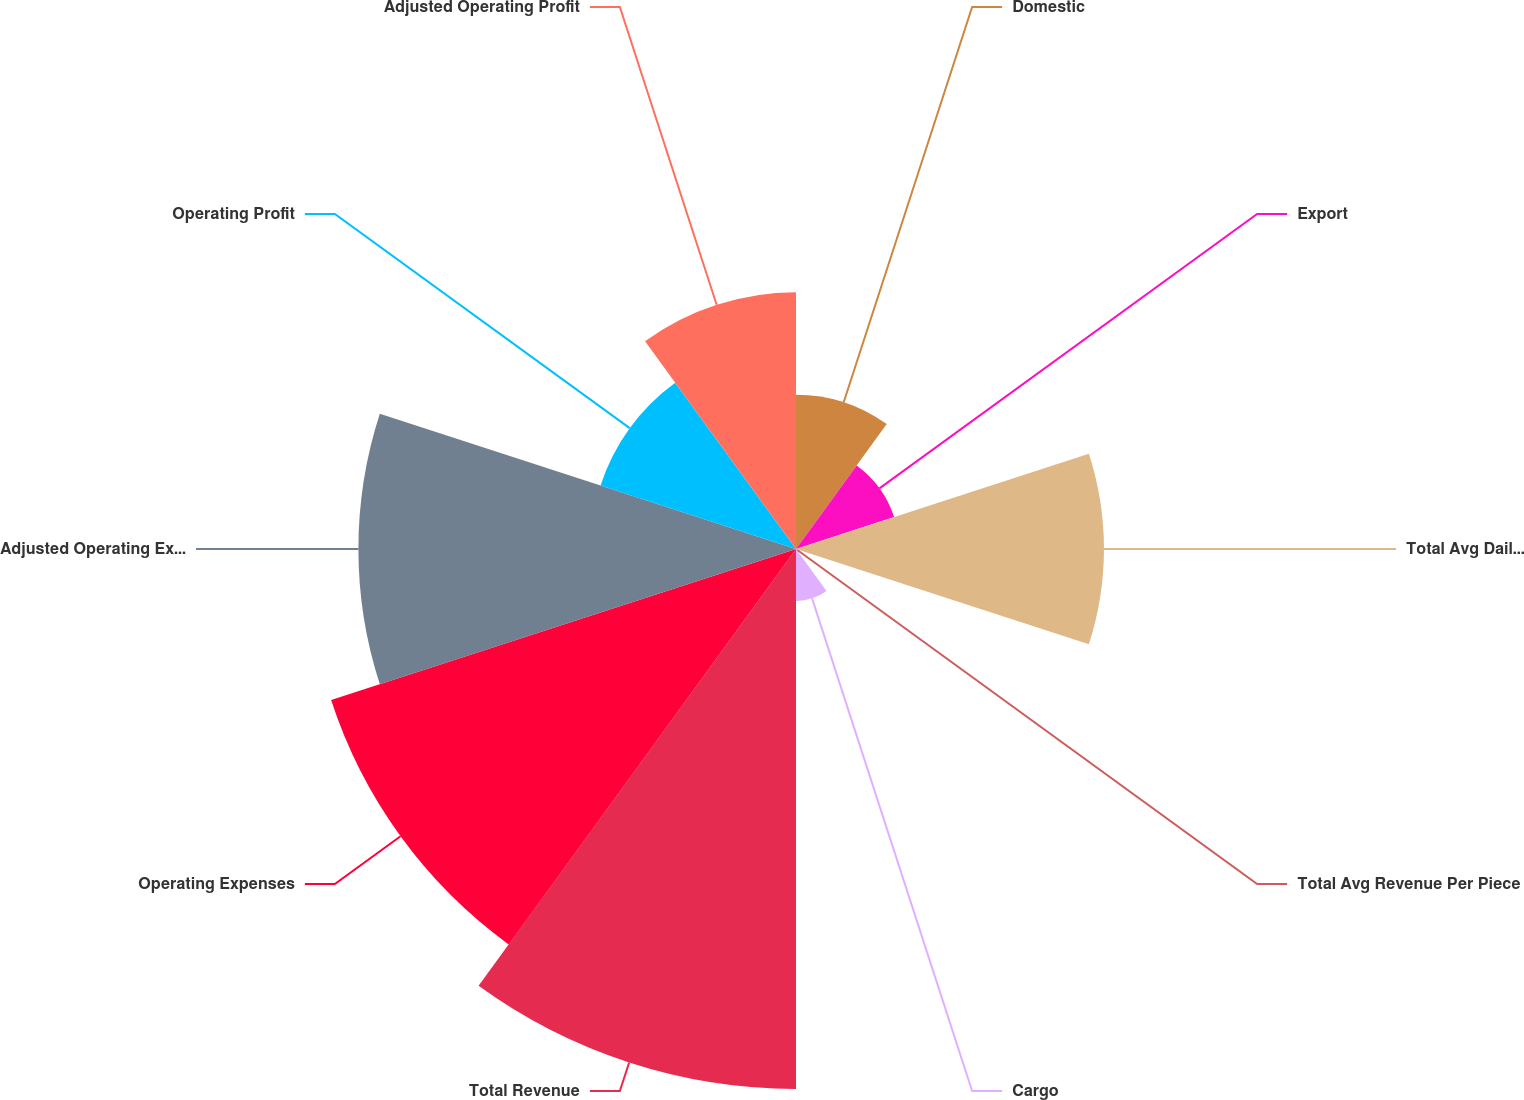Convert chart to OTSL. <chart><loc_0><loc_0><loc_500><loc_500><pie_chart><fcel>Domestic<fcel>Export<fcel>Total Avg Daily Package Volume<fcel>Total Avg Revenue Per Piece<fcel>Cargo<fcel>Total Revenue<fcel>Operating Expenses<fcel>Adjusted Operating Expenses<fcel>Operating Profit<fcel>Adjusted Operating Profit<nl><fcel>6.06%<fcel>4.05%<fcel>12.09%<fcel>0.03%<fcel>2.04%<fcel>21.2%<fcel>19.19%<fcel>17.18%<fcel>8.07%<fcel>10.08%<nl></chart> 